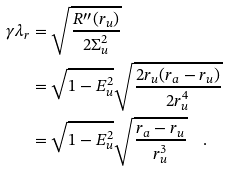Convert formula to latex. <formula><loc_0><loc_0><loc_500><loc_500>\gamma \lambda _ { r } & = \sqrt { \frac { R ^ { \prime \prime } ( r _ { u } ) } { 2 \Sigma _ { u } ^ { 2 } } } \\ & = \sqrt { 1 - E _ { u } ^ { 2 } } \sqrt { \frac { 2 r _ { u } ( r _ { a } - r _ { u } ) } { 2 r _ { u } ^ { 4 } } } \\ & = \sqrt { 1 - E _ { u } ^ { 2 } } \sqrt { \frac { r _ { a } - r _ { u } } { r _ { u } ^ { 3 } } } \quad .</formula> 